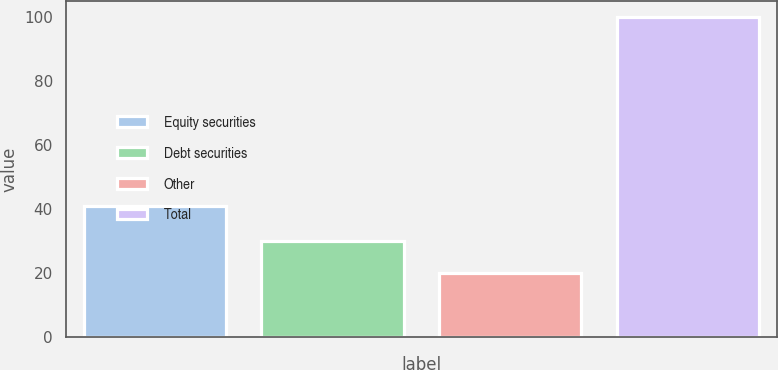Convert chart to OTSL. <chart><loc_0><loc_0><loc_500><loc_500><bar_chart><fcel>Equity securities<fcel>Debt securities<fcel>Other<fcel>Total<nl><fcel>41<fcel>30<fcel>20<fcel>100<nl></chart> 